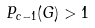<formula> <loc_0><loc_0><loc_500><loc_500>P _ { c - 1 } ( G ) > 1</formula> 